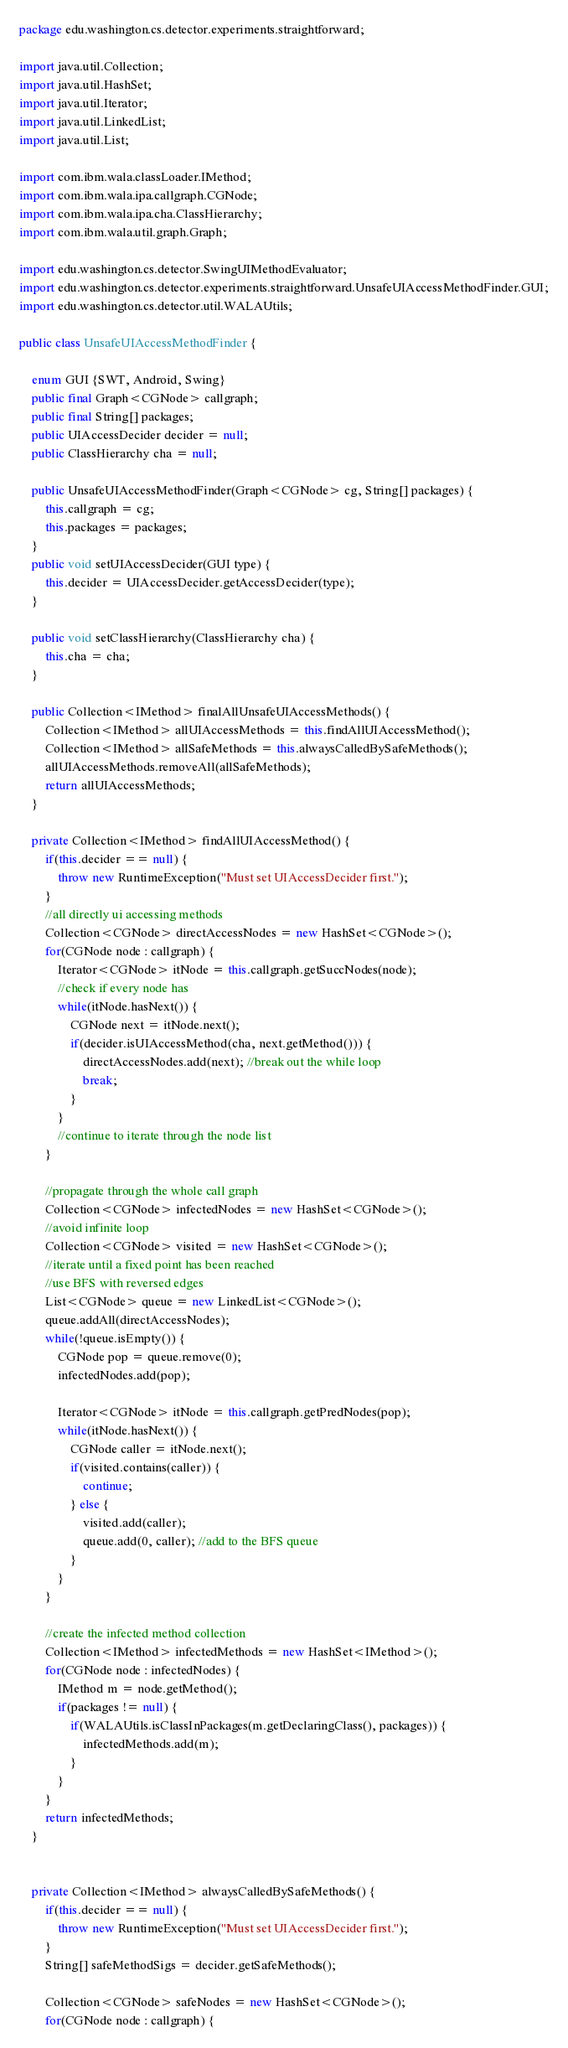<code> <loc_0><loc_0><loc_500><loc_500><_Java_>package edu.washington.cs.detector.experiments.straightforward;

import java.util.Collection;
import java.util.HashSet;
import java.util.Iterator;
import java.util.LinkedList;
import java.util.List;

import com.ibm.wala.classLoader.IMethod;
import com.ibm.wala.ipa.callgraph.CGNode;
import com.ibm.wala.ipa.cha.ClassHierarchy;
import com.ibm.wala.util.graph.Graph;

import edu.washington.cs.detector.SwingUIMethodEvaluator;
import edu.washington.cs.detector.experiments.straightforward.UnsafeUIAccessMethodFinder.GUI;
import edu.washington.cs.detector.util.WALAUtils;

public class UnsafeUIAccessMethodFinder {
	
	enum GUI {SWT, Android, Swing}
	public final Graph<CGNode> callgraph;
	public final String[] packages;
	public UIAccessDecider decider = null;
	public ClassHierarchy cha = null;
	
	public UnsafeUIAccessMethodFinder(Graph<CGNode> cg, String[] packages) {
		this.callgraph = cg;
		this.packages = packages;
	}
	public void setUIAccessDecider(GUI type) {
		this.decider = UIAccessDecider.getAccessDecider(type);
	}
	
	public void setClassHierarchy(ClassHierarchy cha) {
		this.cha = cha;
	}
	
	public Collection<IMethod> finalAllUnsafeUIAccessMethods() {
		Collection<IMethod> allUIAccessMethods = this.findAllUIAccessMethod();
		Collection<IMethod> allSafeMethods = this.alwaysCalledBySafeMethods();
		allUIAccessMethods.removeAll(allSafeMethods);
		return allUIAccessMethods;
	}
	
	private Collection<IMethod> findAllUIAccessMethod() {
		if(this.decider == null) {
		    throw new RuntimeException("Must set UIAccessDecider first.");	
		}
		//all directly ui accessing methods
		Collection<CGNode> directAccessNodes = new HashSet<CGNode>();
		for(CGNode node : callgraph) {
			Iterator<CGNode> itNode = this.callgraph.getSuccNodes(node);
			//check if every node has
			while(itNode.hasNext()) {
				CGNode next = itNode.next();
				if(decider.isUIAccessMethod(cha, next.getMethod())) {
					directAccessNodes.add(next); //break out the while loop
					break;
				}
			}
			//continue to iterate through the node list
		}
		
		//propagate through the whole call graph
		Collection<CGNode> infectedNodes = new HashSet<CGNode>();
		//avoid infinite loop
		Collection<CGNode> visited = new HashSet<CGNode>();
		//iterate until a fixed point has been reached
		//use BFS with reversed edges
		List<CGNode> queue = new LinkedList<CGNode>();
		queue.addAll(directAccessNodes);
		while(!queue.isEmpty()) {
			CGNode pop = queue.remove(0);
			infectedNodes.add(pop);
			
			Iterator<CGNode> itNode = this.callgraph.getPredNodes(pop);
			while(itNode.hasNext()) {
				CGNode caller = itNode.next();
				if(visited.contains(caller)) {
					continue;
				} else {
					visited.add(caller);
					queue.add(0, caller); //add to the BFS queue
				}
			}
		}
		
		//create the infected method collection
		Collection<IMethod> infectedMethods = new HashSet<IMethod>();
		for(CGNode node : infectedNodes) {
			IMethod m = node.getMethod();
			if(packages != null) {
				if(WALAUtils.isClassInPackages(m.getDeclaringClass(), packages)) {
					infectedMethods.add(m);
				}
			}
		}
		return infectedMethods;
	}

	
	private Collection<IMethod> alwaysCalledBySafeMethods() {
		if(this.decider == null) {
		    throw new RuntimeException("Must set UIAccessDecider first.");	
		}
		String[] safeMethodSigs = decider.getSafeMethods();
		
		Collection<CGNode> safeNodes = new HashSet<CGNode>();
		for(CGNode node : callgraph) {</code> 